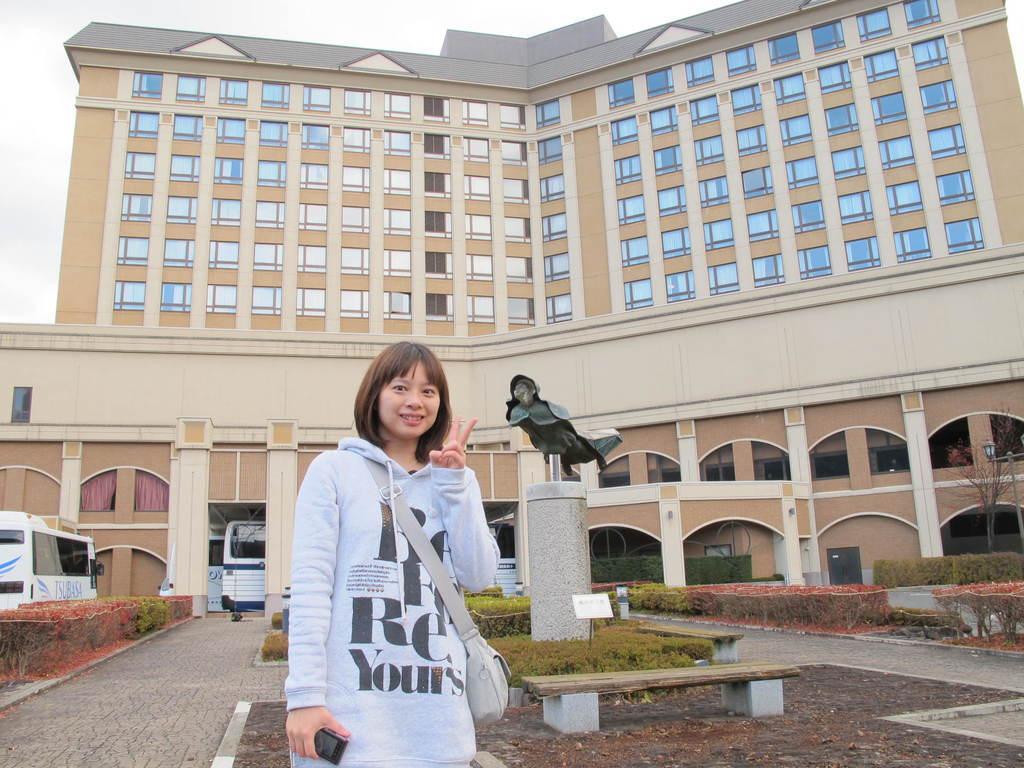How would you summarize this image in a sentence or two? This picture is clicked outside the city. Woman in front of this picture is wearing a bag and she is carrying mobile phone in her hands. Beside her, we see a bench and behind that, we see grass and a pillar on which statue is placed. Behind that, we see a building. On the right corner of the picture, we see tree and also streetlamp. On the left corner, we see bus and on top we see sky. 